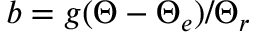Convert formula to latex. <formula><loc_0><loc_0><loc_500><loc_500>b = g ( \Theta - \Theta _ { e } ) / \Theta _ { r }</formula> 